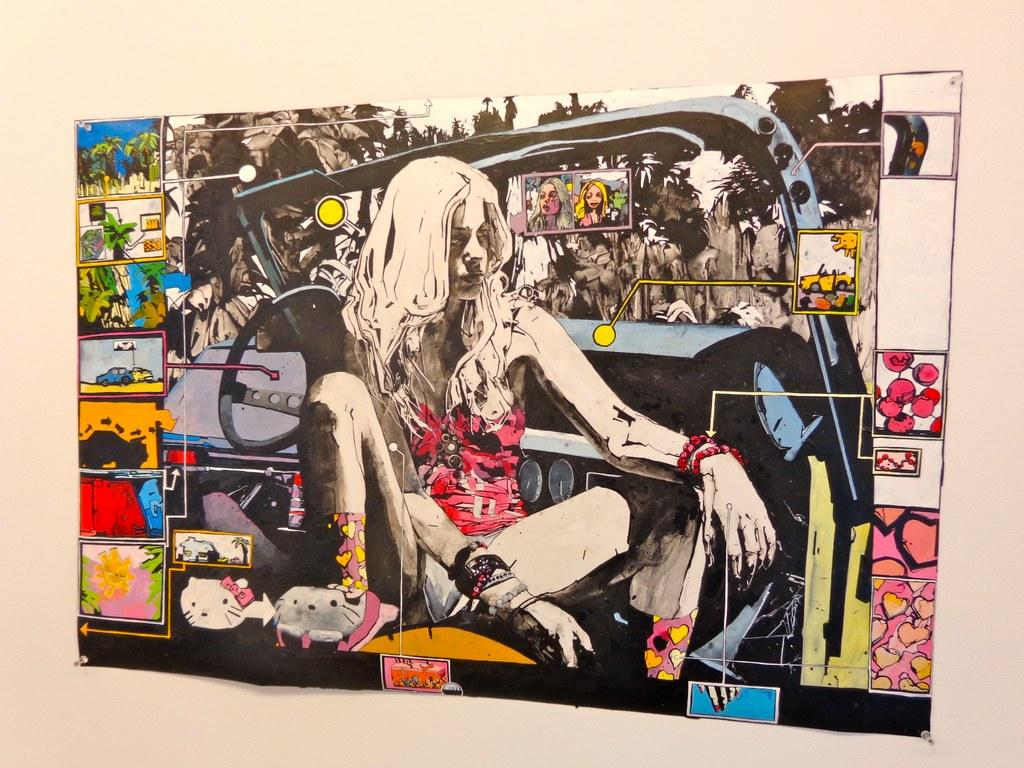What is the main subject of the image? The main subject of the image is a painted paper. How is the painted paper displayed in the image? The painted paper is stuck to the wall. What is depicted on the painted paper? There is a woman depicted on the painted paper, along with other painted pictures. What type of house is depicted in the fog in the image? There is no house or fog present in the image; it features a painted paper with a woman and other painted pictures. What caption is written below the painted paper in the image? There is no caption visible in the image; it only shows the painted paper with the depicted woman and other painted pictures. 